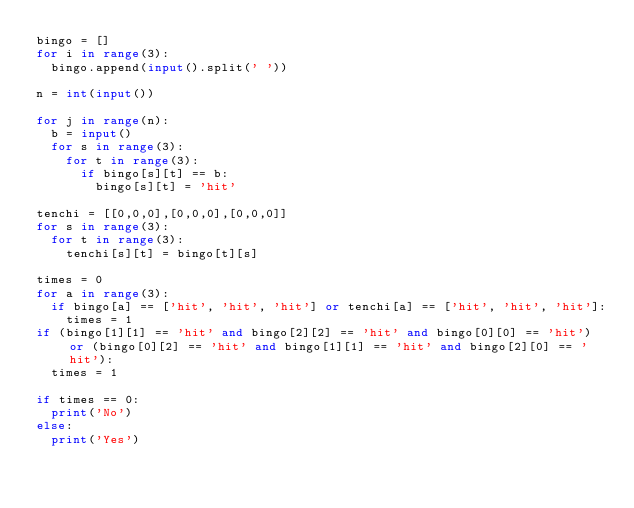Convert code to text. <code><loc_0><loc_0><loc_500><loc_500><_Python_>bingo = []
for i in range(3):
  bingo.append(input().split(' '))
  
n = int(input())

for j in range(n):
  b = input()
  for s in range(3):
    for t in range(3):
      if bingo[s][t] == b:
        bingo[s][t] = 'hit'
        
tenchi = [[0,0,0],[0,0,0],[0,0,0]]
for s in range(3):
  for t in range(3):
    tenchi[s][t] = bingo[t][s]
    
times = 0
for a in range(3):
  if bingo[a] == ['hit', 'hit', 'hit'] or tenchi[a] == ['hit', 'hit', 'hit']:
    times = 1
if (bingo[1][1] == 'hit' and bingo[2][2] == 'hit' and bingo[0][0] == 'hit') or (bingo[0][2] == 'hit' and bingo[1][1] == 'hit' and bingo[2][0] == 'hit'):
  times = 1

if times == 0:
  print('No')
else:
  print('Yes')</code> 